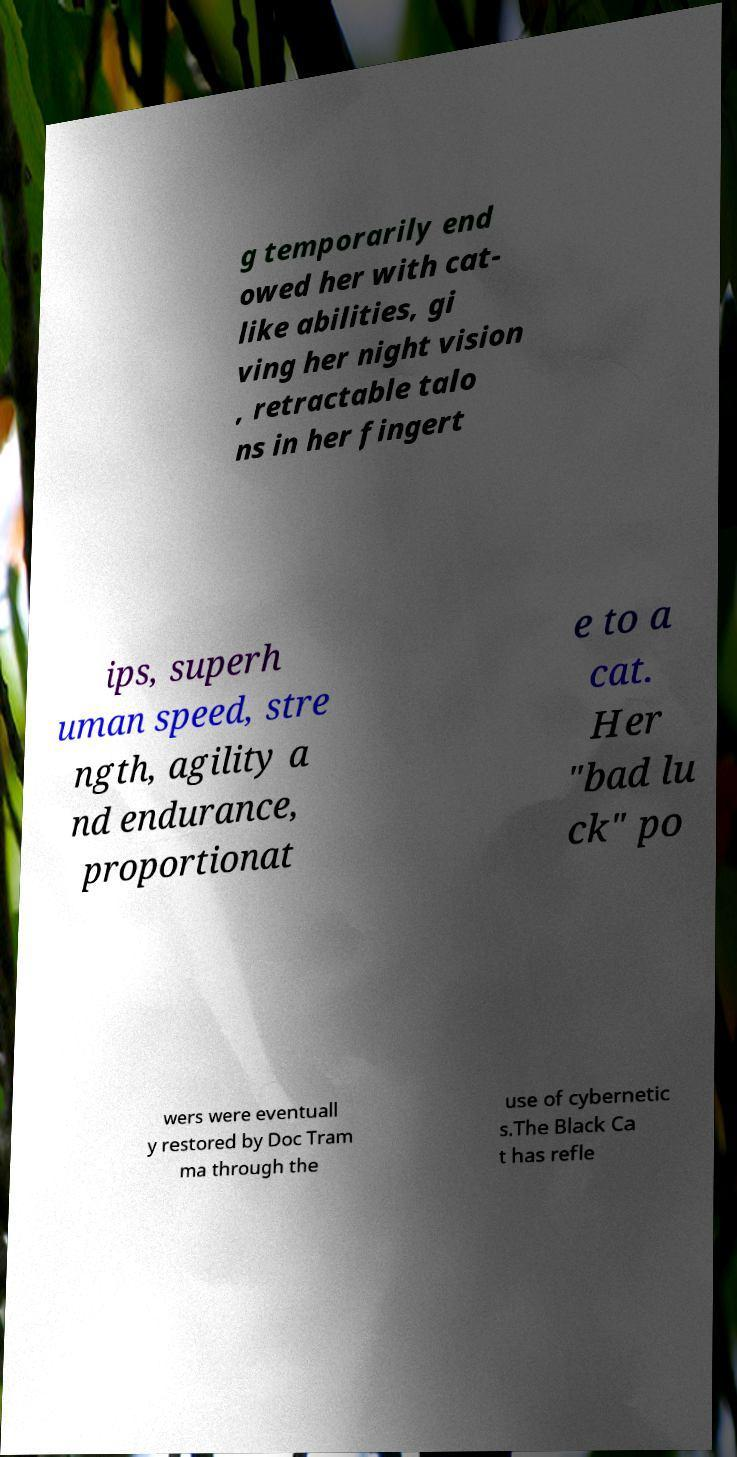Can you read and provide the text displayed in the image?This photo seems to have some interesting text. Can you extract and type it out for me? g temporarily end owed her with cat- like abilities, gi ving her night vision , retractable talo ns in her fingert ips, superh uman speed, stre ngth, agility a nd endurance, proportionat e to a cat. Her "bad lu ck" po wers were eventuall y restored by Doc Tram ma through the use of cybernetic s.The Black Ca t has refle 